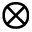Convert formula to latex. <formula><loc_0><loc_0><loc_500><loc_500>\otimes</formula> 